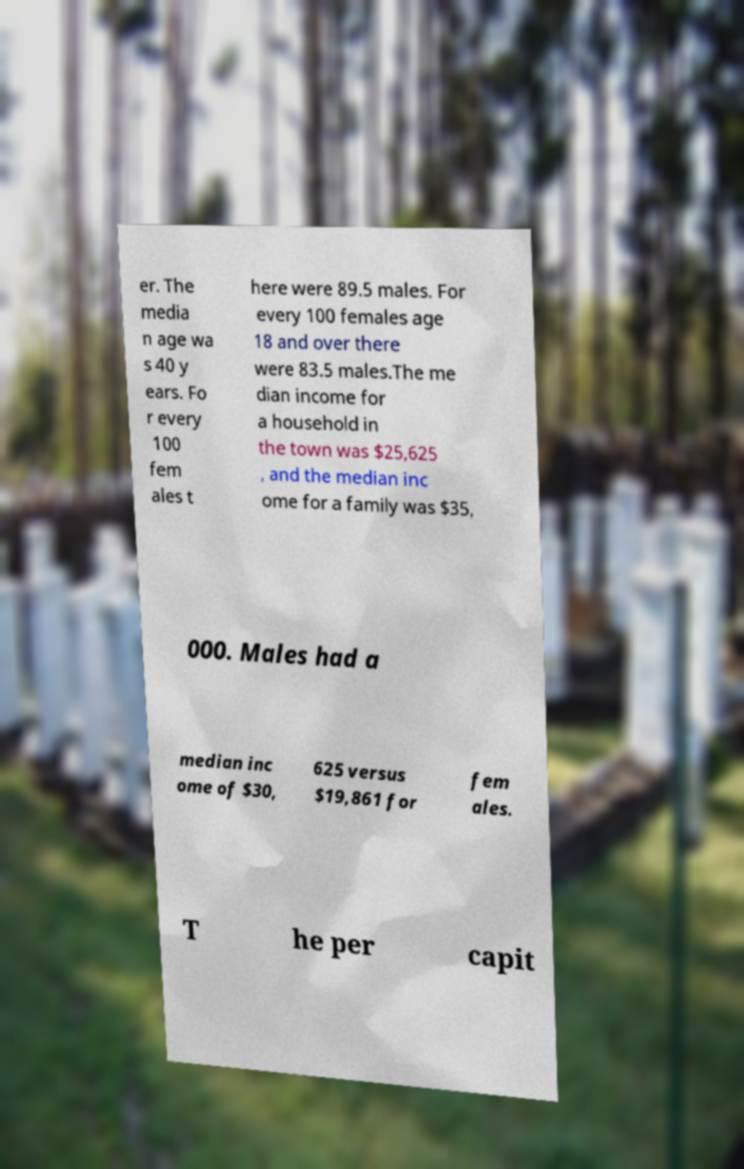Could you extract and type out the text from this image? er. The media n age wa s 40 y ears. Fo r every 100 fem ales t here were 89.5 males. For every 100 females age 18 and over there were 83.5 males.The me dian income for a household in the town was $25,625 , and the median inc ome for a family was $35, 000. Males had a median inc ome of $30, 625 versus $19,861 for fem ales. T he per capit 